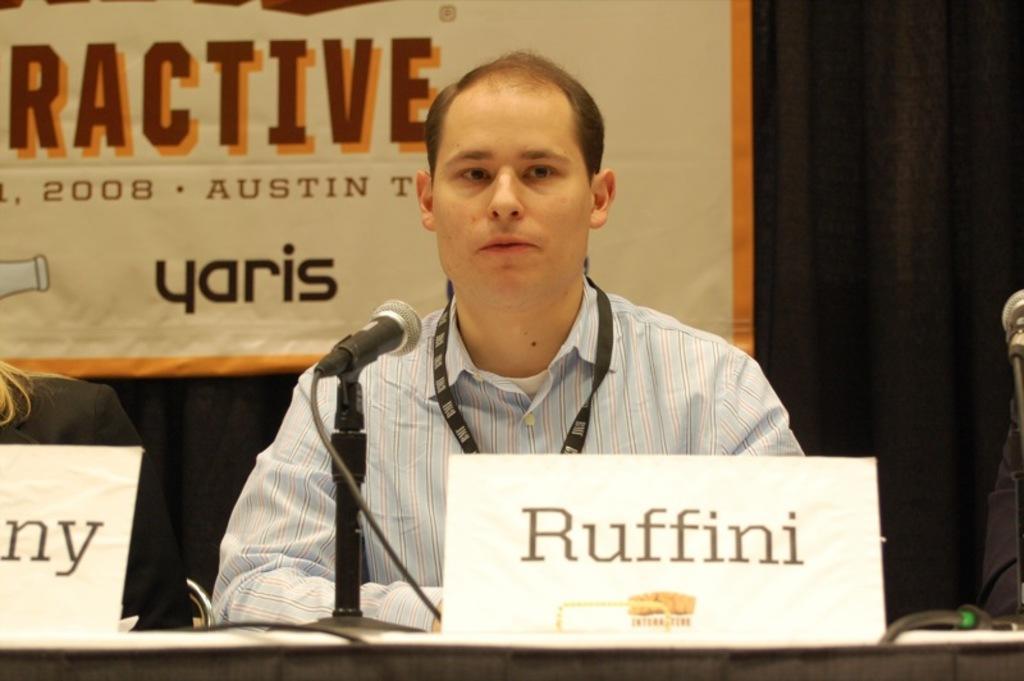Describe this image in one or two sentences. In this image we can see there are persons sitting. And there is a table, on the table there are boards and microphone. At the back there is a curtain and banner attached to it. 